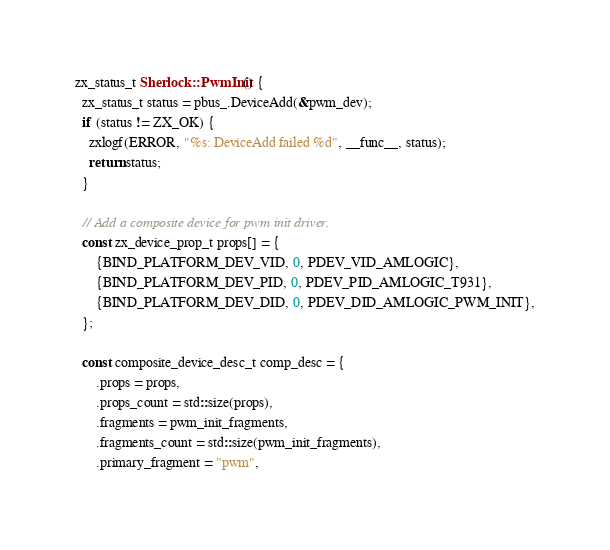Convert code to text. <code><loc_0><loc_0><loc_500><loc_500><_C++_>zx_status_t Sherlock::PwmInit() {
  zx_status_t status = pbus_.DeviceAdd(&pwm_dev);
  if (status != ZX_OK) {
    zxlogf(ERROR, "%s: DeviceAdd failed %d", __func__, status);
    return status;
  }

  // Add a composite device for pwm init driver.
  const zx_device_prop_t props[] = {
      {BIND_PLATFORM_DEV_VID, 0, PDEV_VID_AMLOGIC},
      {BIND_PLATFORM_DEV_PID, 0, PDEV_PID_AMLOGIC_T931},
      {BIND_PLATFORM_DEV_DID, 0, PDEV_DID_AMLOGIC_PWM_INIT},
  };

  const composite_device_desc_t comp_desc = {
      .props = props,
      .props_count = std::size(props),
      .fragments = pwm_init_fragments,
      .fragments_count = std::size(pwm_init_fragments),
      .primary_fragment = "pwm",</code> 